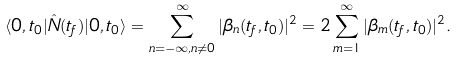<formula> <loc_0><loc_0><loc_500><loc_500>\langle 0 , t _ { 0 } | \hat { N } ( t _ { f } ) | 0 , t _ { 0 } \rangle = \sum _ { n = - \infty , n \neq 0 } ^ { \infty } | \beta _ { n } ( t _ { f } , t _ { 0 } ) | ^ { 2 } = 2 \sum _ { m = 1 } ^ { \infty } | \beta _ { m } ( t _ { f } , t _ { 0 } ) | ^ { 2 } .</formula> 